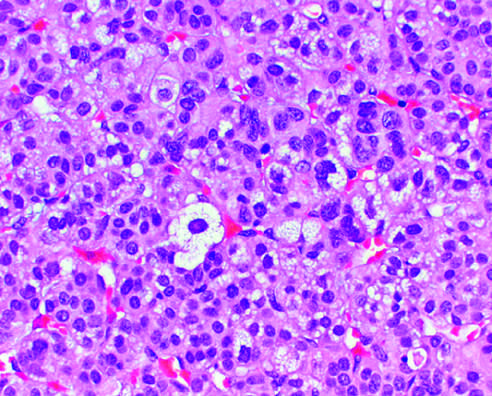the adenoma is distinguished from nodular hyperplasia by whose solitary , circumscribed nature?
Answer the question using a single word or phrase. Its 